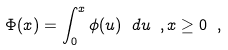Convert formula to latex. <formula><loc_0><loc_0><loc_500><loc_500>\Phi ( x ) = \int _ { 0 } ^ { x } \phi ( u ) \ d u \ , x \geq 0 \ ,</formula> 